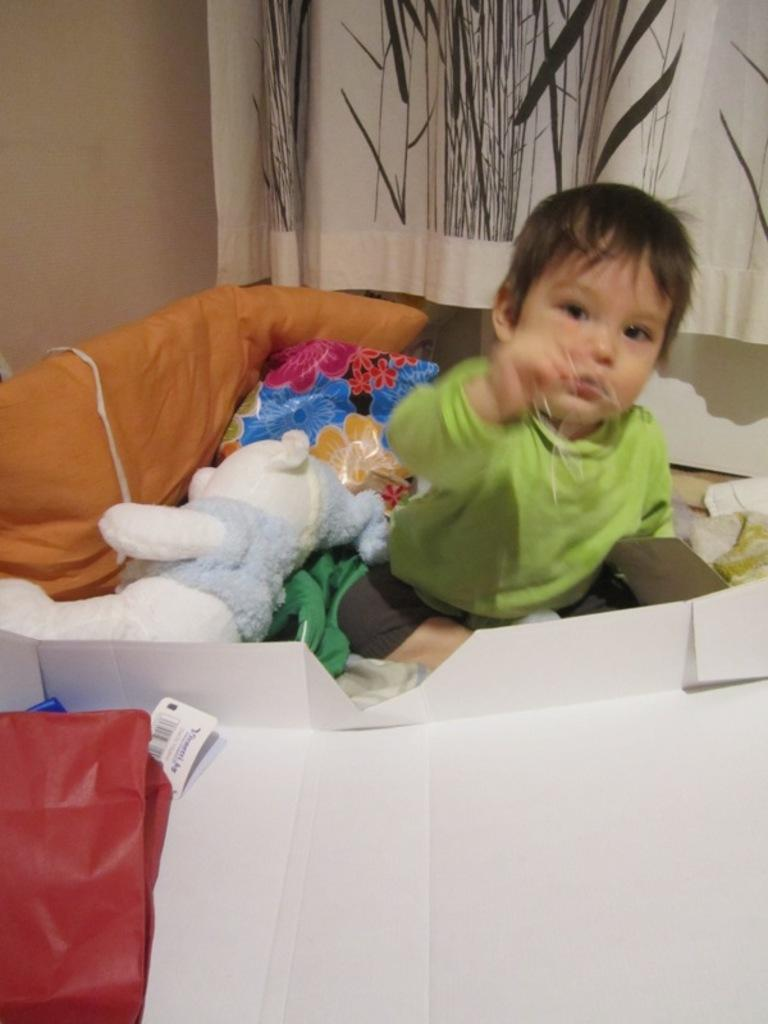What is the kid doing in the image? The kid is sitting in the image. What is located beside the kid? There is a toy beside the kid. What type of furniture or objects can be seen in the image? There are pillows and a paper in the image. Can you describe the setting of the image? There is a curtain on the right side of the image and a wall in the background. How many objects can be seen in the image? There are other objects in the image, in addition to the kid, toy, pillows, paper, curtain, and wall. What type of fan is being used by the kid in the image? There is no fan present in the image; the kid is simply sitting with a toy beside them. 